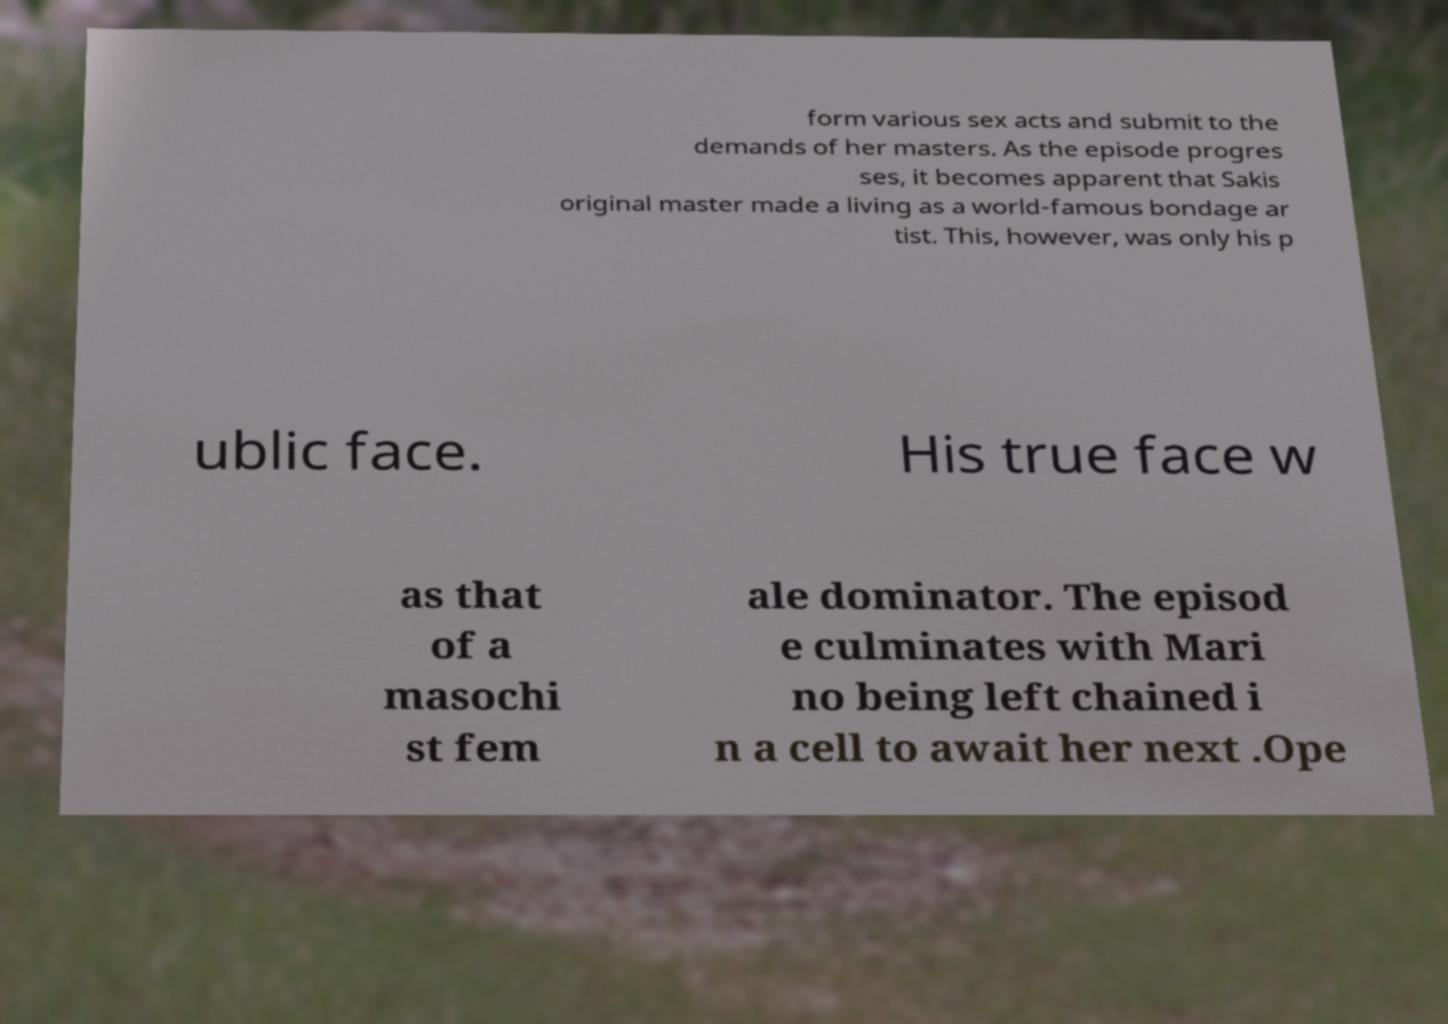Could you extract and type out the text from this image? form various sex acts and submit to the demands of her masters. As the episode progres ses, it becomes apparent that Sakis original master made a living as a world-famous bondage ar tist. This, however, was only his p ublic face. His true face w as that of a masochi st fem ale dominator. The episod e culminates with Mari no being left chained i n a cell to await her next .Ope 